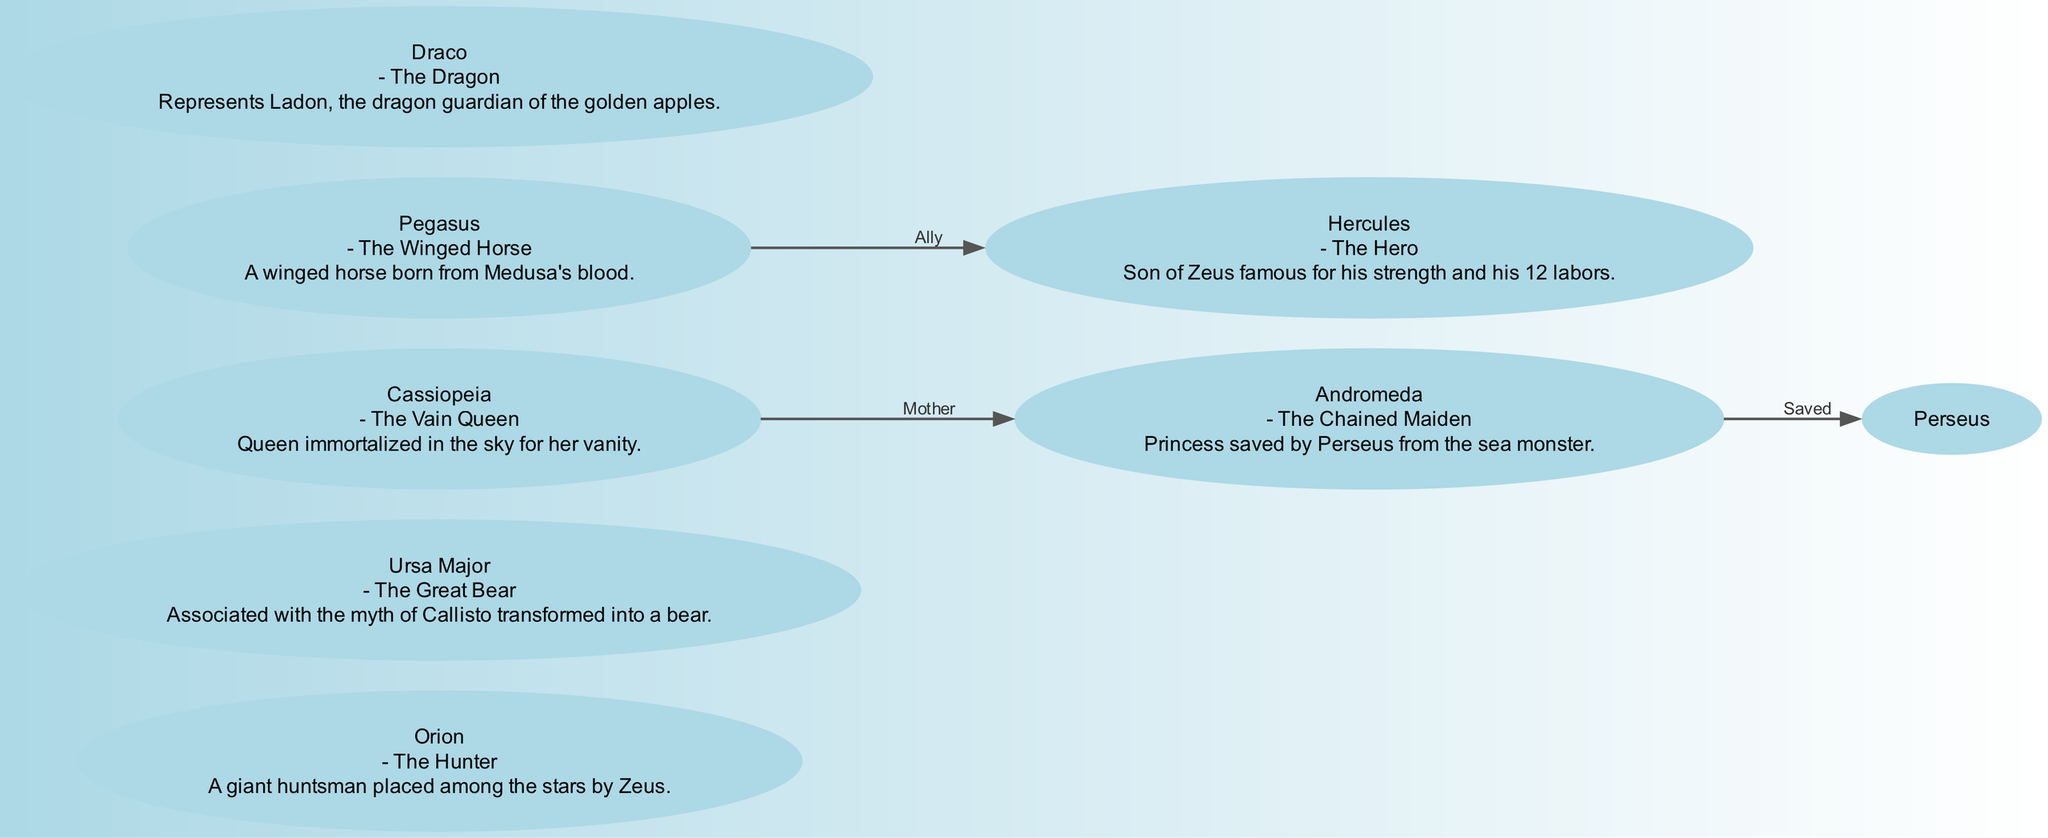What is the total number of nodes in the diagram? The diagram contains a list of nodes representing star constellations, and by counting them, we find that there are a total of 7 nodes.
Answer: 7 Which constellation is associated with the myth of Callisto? By examining the descriptions of the constellations, Ursa Major is specifically mentioned to be related to the myth of Callisto.
Answer: Ursa Major Who is Andromeda's mother in the myth? Looking at the relationships in the diagram shows that Cassiopeia is connected to Andromeda with the label "Mother," indicating her as Andromeda's mother.
Answer: Cassiopeia What character saved Andromeda? The edge labeled "Saved" from Andromeda points to Perseus, indicating that he is the character that saved her from the sea monster.
Answer: Perseus Which constellation is known as "The Hero"? According to the labels, Hercules is described as "The Hero," indicating his significance among the constellations.
Answer: Hercules How many edges are depicted in the diagram? By counting the edges that represent relationships between the constellations, we find there are 3 edges connecting different nodes.
Answer: 3 What does Pegasus represent in mythology? The description of Pegasus states that it is "A winged horse born from Medusa's blood," providing a clear insight into its mythological background.
Answer: A winged horse Which two constellations are connected by the relationship "Ally"? The edge labeled "Ally" connects Pegasus to Hercules, showing that they share this particular relationship in the diagram.
Answer: Pegasus and Hercules Which constellation is depicted as "The Vain Queen"? The description for Cassiopeia in the diagram explicitly refers to her as "The Vain Queen," thus answering the question regarding her identity.
Answer: Cassiopeia 